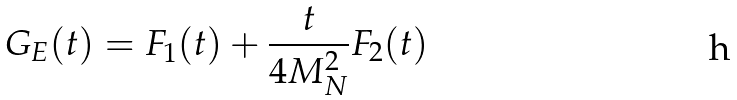Convert formula to latex. <formula><loc_0><loc_0><loc_500><loc_500>G _ { E } ( t ) = F _ { 1 } ( t ) + \frac { t } { 4 M _ { N } ^ { 2 } } F _ { 2 } ( t )</formula> 